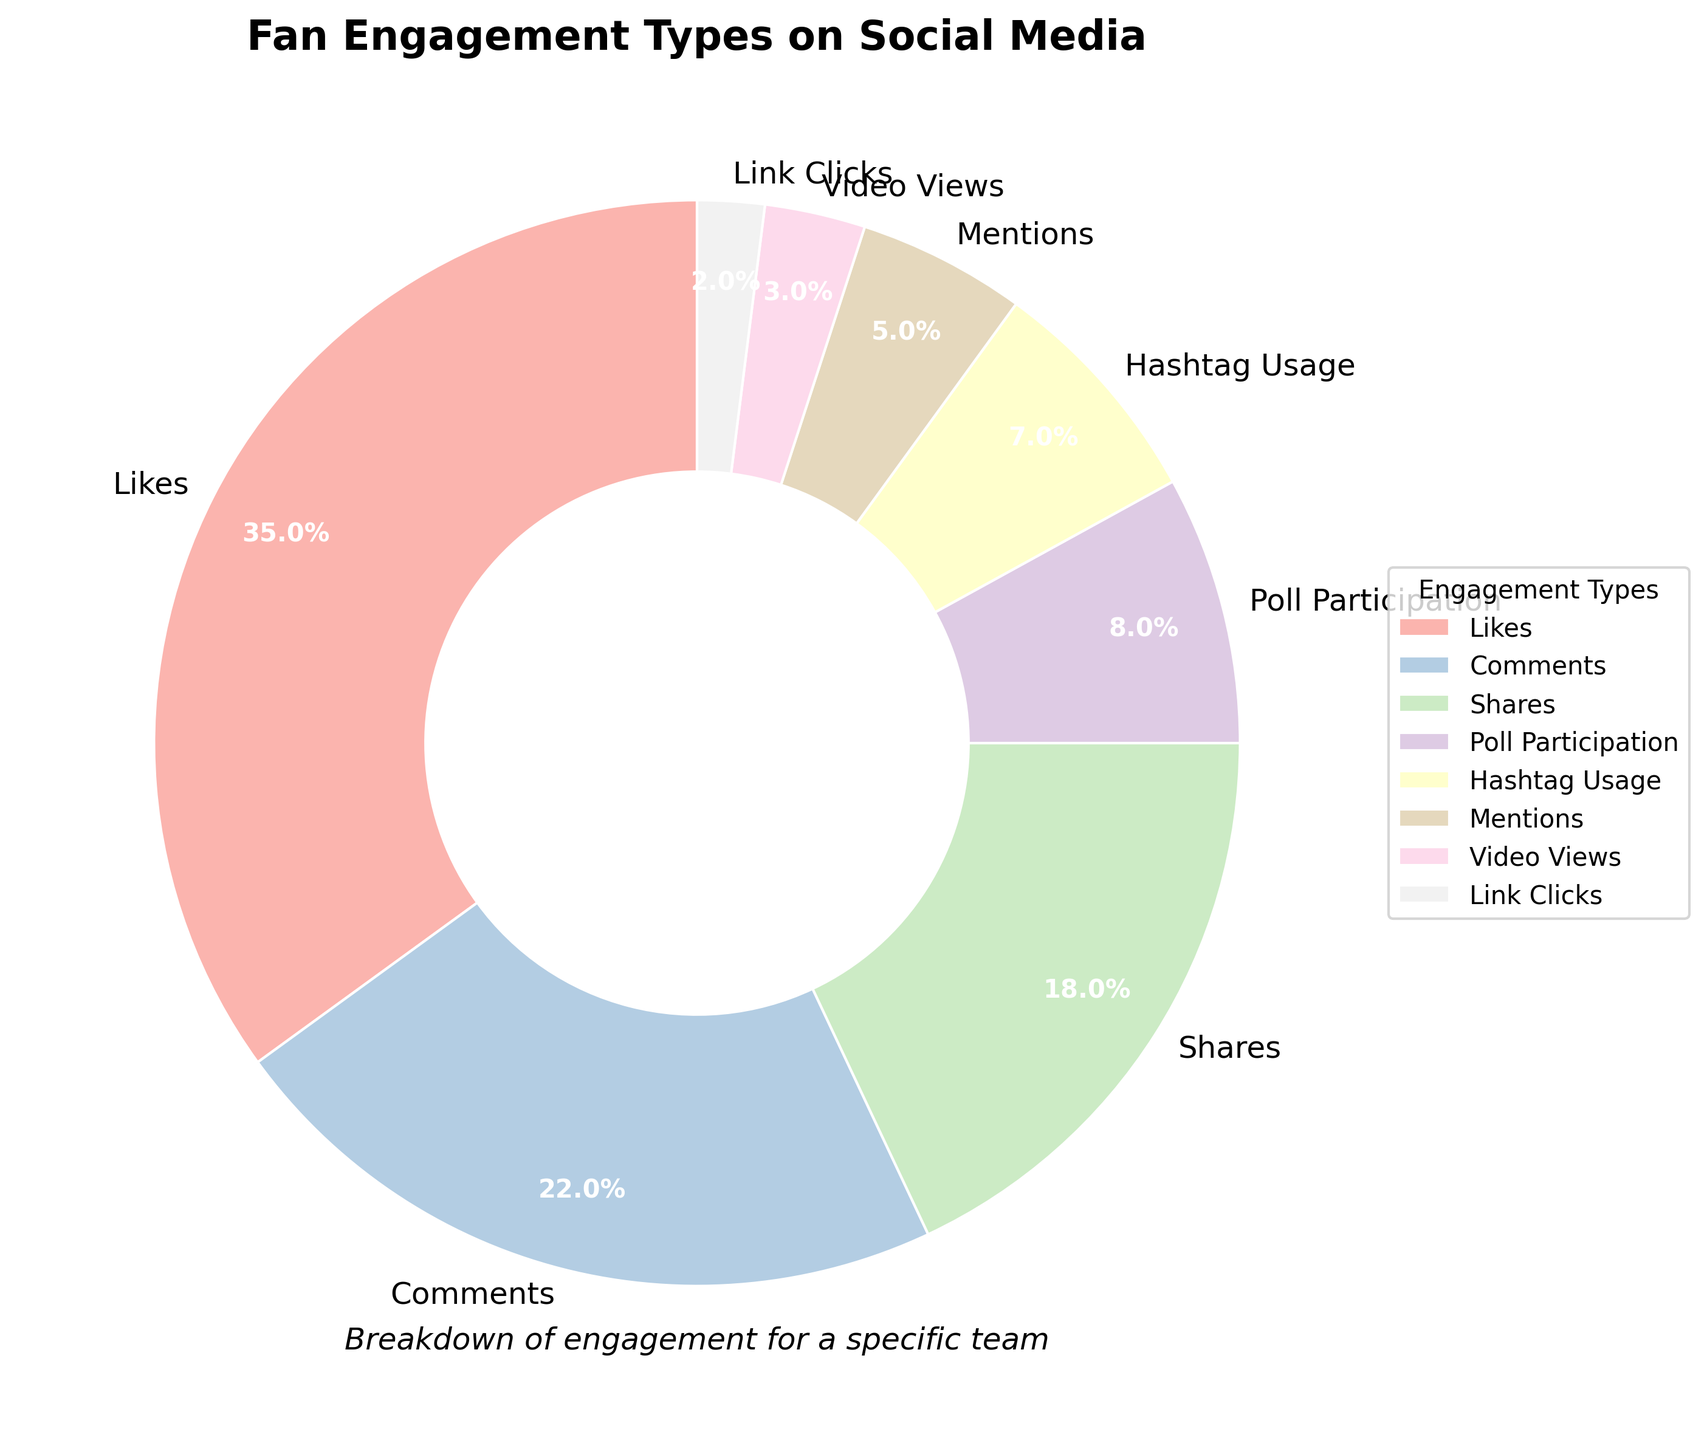Which engagement type has the highest percentage? The engagement type with the highest percentage should be the largest section in the pie chart. By looking at the chart, we see that "Likes" occupies the largest section at 35%.
Answer: Likes Which engagement type has the lowest percentage? The engagement type with the lowest percentage is represented by the smallest section in the pie chart. "Link Clicks" occupies the smallest section at 2%.
Answer: Link Clicks What is the combined percentage of "Shares" and "Poll Participation"? The pie chart provides individual percentages for each type. By summing the percentages of "Shares" (18%) and "Poll Participation" (8%), we get a total of 26%.
Answer: 26% How much greater is the percentage of "Comments" compared to "Mentions"? The percentage of "Comments" is 22% and "Mentions" is 5%. To find the difference, subtract the smaller percentage from the larger one: 22% - 5% = 17%.
Answer: 17% What is the average percentage of "Video Views," "Link Clicks," and "Hashtag Usage"? The percentages are 3% for "Video Views," 2% for "Link Clicks," and 7% for "Hashtag Usage." Sum these values and divide by 3 to get the average: (3% + 2% + 7%) / 3 = 12% / 3 = 4%.
Answer: 4% Which color represents the "Comments" section in the pie chart? By examining the colors within the pie chart and matching them with the legend, the "Comments" section is represented by a certain color from the Pastel1 palette. The pie chart shows "Comments" in a particular pastel shade.
Answer: Specific shade from Pastel1 Is there more engagement in "Shares" or "Hashtag Usage"? The pie chart shows the percentage for "Shares" as 18% and for "Hashtag Usage" as 7%. Since 18% is greater than 7%, there is more engagement in "Shares".
Answer: Shares Do "Comments" and "Likes" together constitute more than half of the total engagement? The pie chart shows "Comments" at 22% and "Likes" at 35%. Adding these percentages, we get 22% + 35% = 57%, which is more than half.
Answer: Yes What is the difference in engagement percentage between the top two engagement types? The top two engagement types are "Likes" (35%) and "Comments" (22%). The difference is calculated as 35% - 22% = 13%.
Answer: 13% How do the visual sizes of "Poll Participation" and "Video Views" compare? "Poll Participation" occupies 8% of the pie chart, while "Video Views" occupies 3%. Visually, the section for "Poll Participation" is more than twice as large as the section for "Video Views".
Answer: Poll Participation is larger 